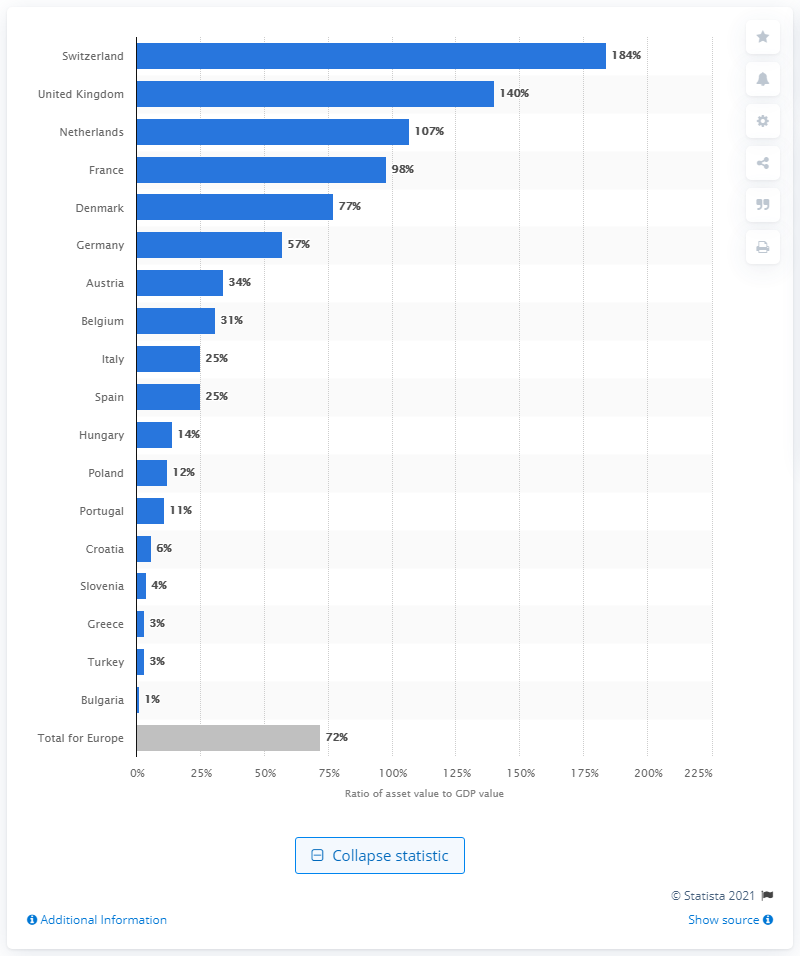Point out several critical features in this image. At the end of 2018, the ratio of assets to GDP in Switzerland was 184%. 